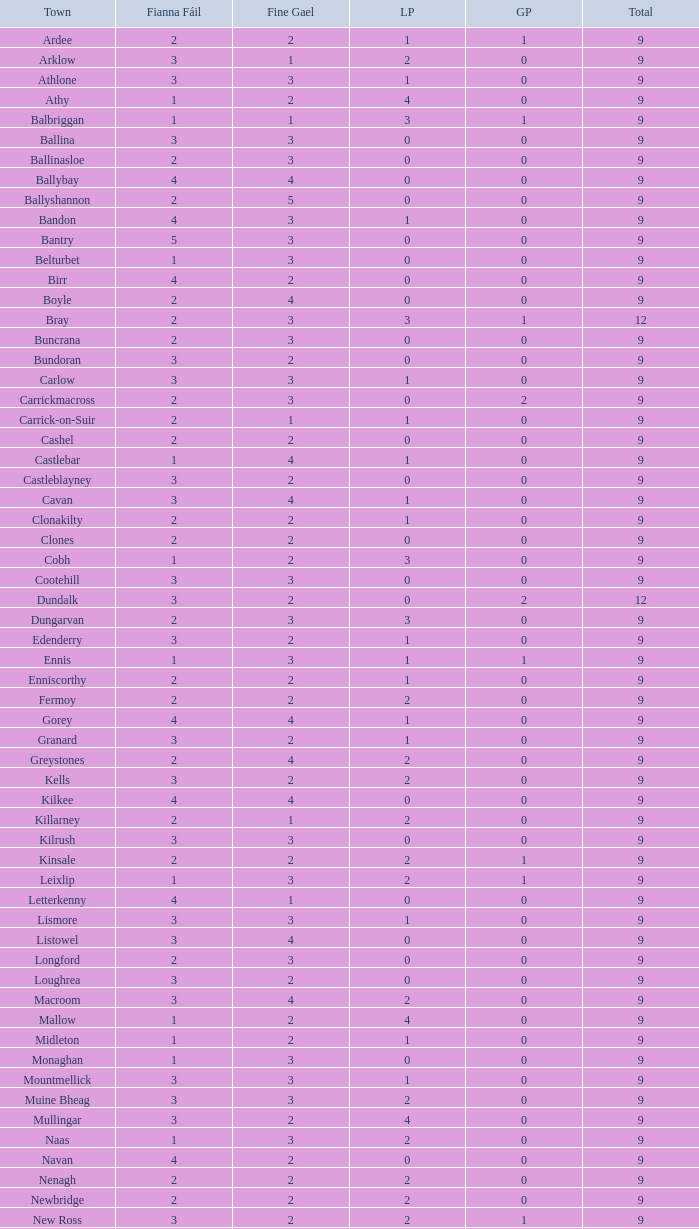What is the lowest number in the Labour Party for the Fianna Fail higher than 5? None. 